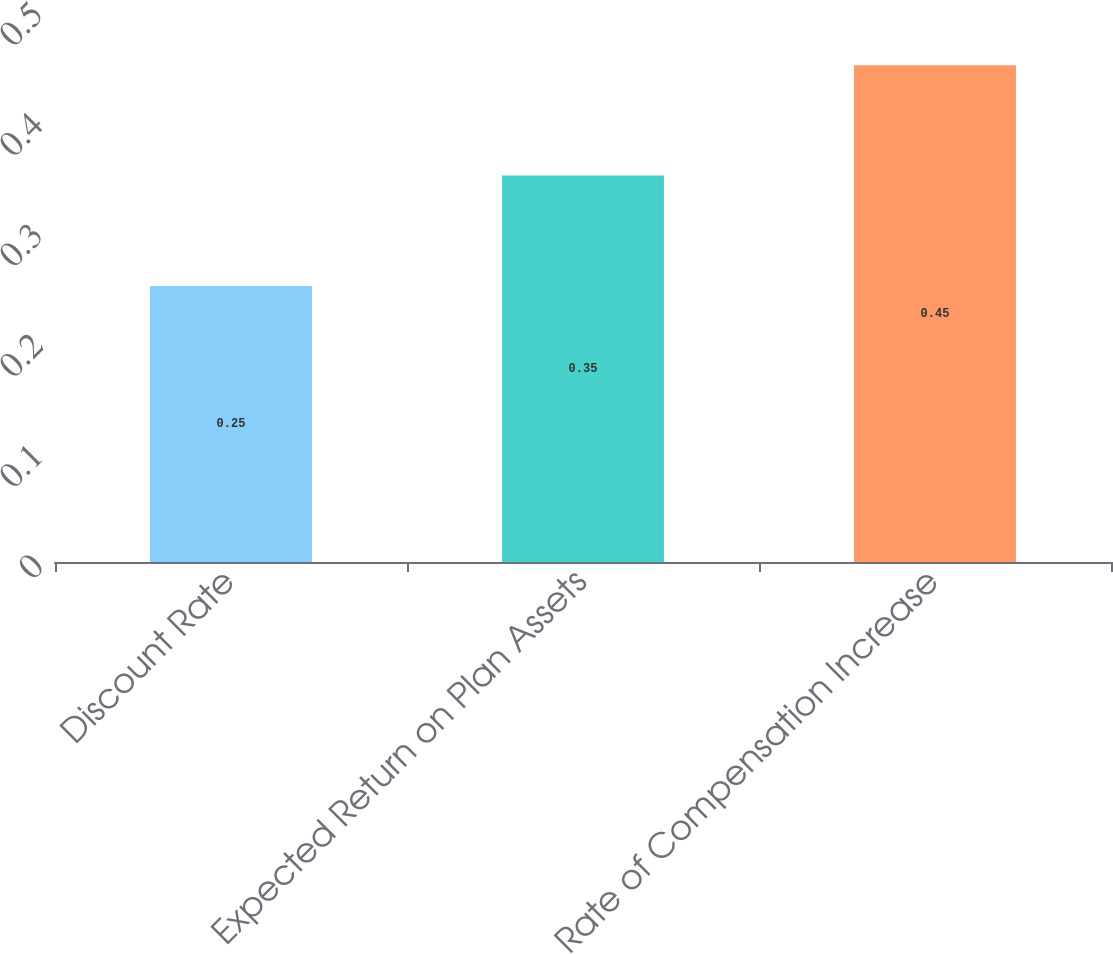<chart> <loc_0><loc_0><loc_500><loc_500><bar_chart><fcel>Discount Rate<fcel>Expected Return on Plan Assets<fcel>Rate of Compensation Increase<nl><fcel>0.25<fcel>0.35<fcel>0.45<nl></chart> 